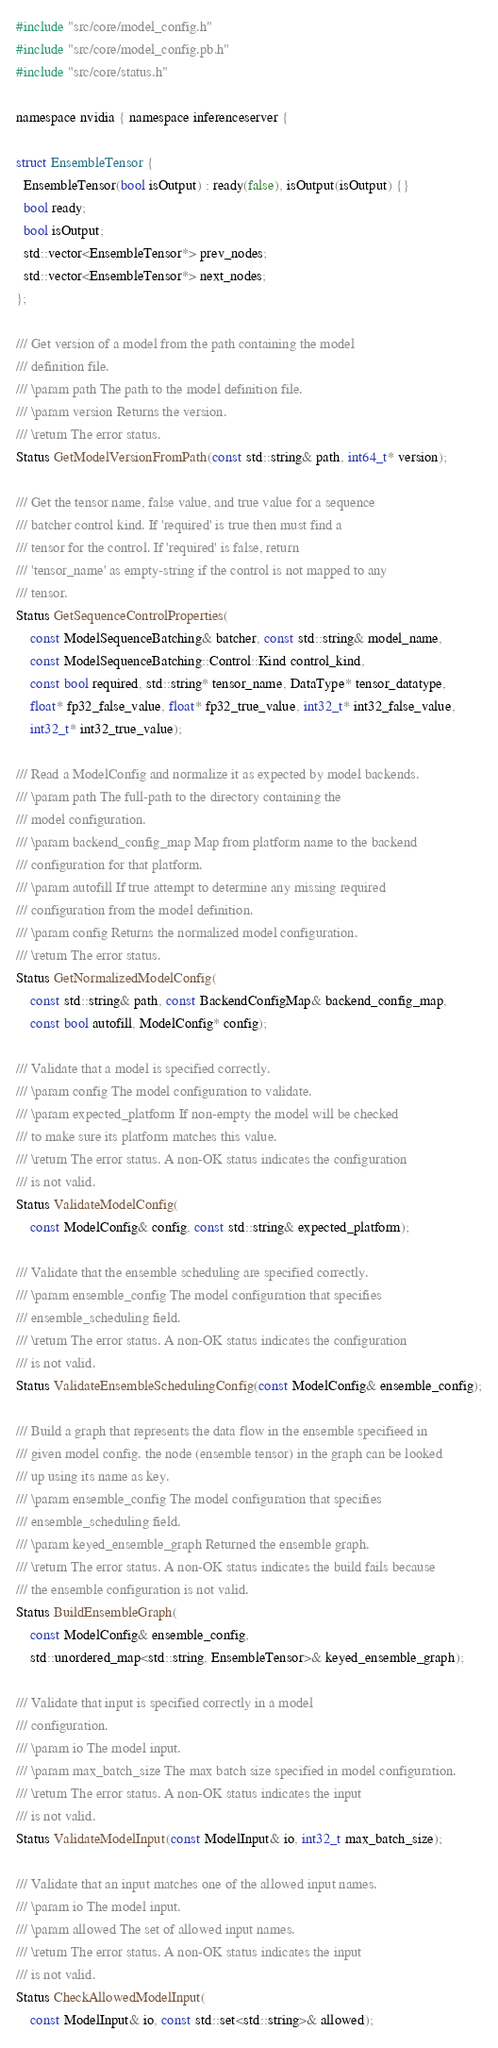Convert code to text. <code><loc_0><loc_0><loc_500><loc_500><_C_>#include "src/core/model_config.h"
#include "src/core/model_config.pb.h"
#include "src/core/status.h"

namespace nvidia { namespace inferenceserver {

struct EnsembleTensor {
  EnsembleTensor(bool isOutput) : ready(false), isOutput(isOutput) {}
  bool ready;
  bool isOutput;
  std::vector<EnsembleTensor*> prev_nodes;
  std::vector<EnsembleTensor*> next_nodes;
};

/// Get version of a model from the path containing the model
/// definition file.
/// \param path The path to the model definition file.
/// \param version Returns the version.
/// \return The error status.
Status GetModelVersionFromPath(const std::string& path, int64_t* version);

/// Get the tensor name, false value, and true value for a sequence
/// batcher control kind. If 'required' is true then must find a
/// tensor for the control. If 'required' is false, return
/// 'tensor_name' as empty-string if the control is not mapped to any
/// tensor.
Status GetSequenceControlProperties(
    const ModelSequenceBatching& batcher, const std::string& model_name,
    const ModelSequenceBatching::Control::Kind control_kind,
    const bool required, std::string* tensor_name, DataType* tensor_datatype,
    float* fp32_false_value, float* fp32_true_value, int32_t* int32_false_value,
    int32_t* int32_true_value);

/// Read a ModelConfig and normalize it as expected by model backends.
/// \param path The full-path to the directory containing the
/// model configuration.
/// \param backend_config_map Map from platform name to the backend
/// configuration for that platform.
/// \param autofill If true attempt to determine any missing required
/// configuration from the model definition.
/// \param config Returns the normalized model configuration.
/// \return The error status.
Status GetNormalizedModelConfig(
    const std::string& path, const BackendConfigMap& backend_config_map,
    const bool autofill, ModelConfig* config);

/// Validate that a model is specified correctly.
/// \param config The model configuration to validate.
/// \param expected_platform If non-empty the model will be checked
/// to make sure its platform matches this value.
/// \return The error status. A non-OK status indicates the configuration
/// is not valid.
Status ValidateModelConfig(
    const ModelConfig& config, const std::string& expected_platform);

/// Validate that the ensemble scheduling are specified correctly.
/// \param ensemble_config The model configuration that specifies
/// ensemble_scheduling field.
/// \return The error status. A non-OK status indicates the configuration
/// is not valid.
Status ValidateEnsembleSchedulingConfig(const ModelConfig& ensemble_config);

/// Build a graph that represents the data flow in the ensemble specifieed in
/// given model config. the node (ensemble tensor) in the graph can be looked
/// up using its name as key.
/// \param ensemble_config The model configuration that specifies
/// ensemble_scheduling field.
/// \param keyed_ensemble_graph Returned the ensemble graph.
/// \return The error status. A non-OK status indicates the build fails because
/// the ensemble configuration is not valid.
Status BuildEnsembleGraph(
    const ModelConfig& ensemble_config,
    std::unordered_map<std::string, EnsembleTensor>& keyed_ensemble_graph);

/// Validate that input is specified correctly in a model
/// configuration.
/// \param io The model input.
/// \param max_batch_size The max batch size specified in model configuration.
/// \return The error status. A non-OK status indicates the input
/// is not valid.
Status ValidateModelInput(const ModelInput& io, int32_t max_batch_size);

/// Validate that an input matches one of the allowed input names.
/// \param io The model input.
/// \param allowed The set of allowed input names.
/// \return The error status. A non-OK status indicates the input
/// is not valid.
Status CheckAllowedModelInput(
    const ModelInput& io, const std::set<std::string>& allowed);
</code> 